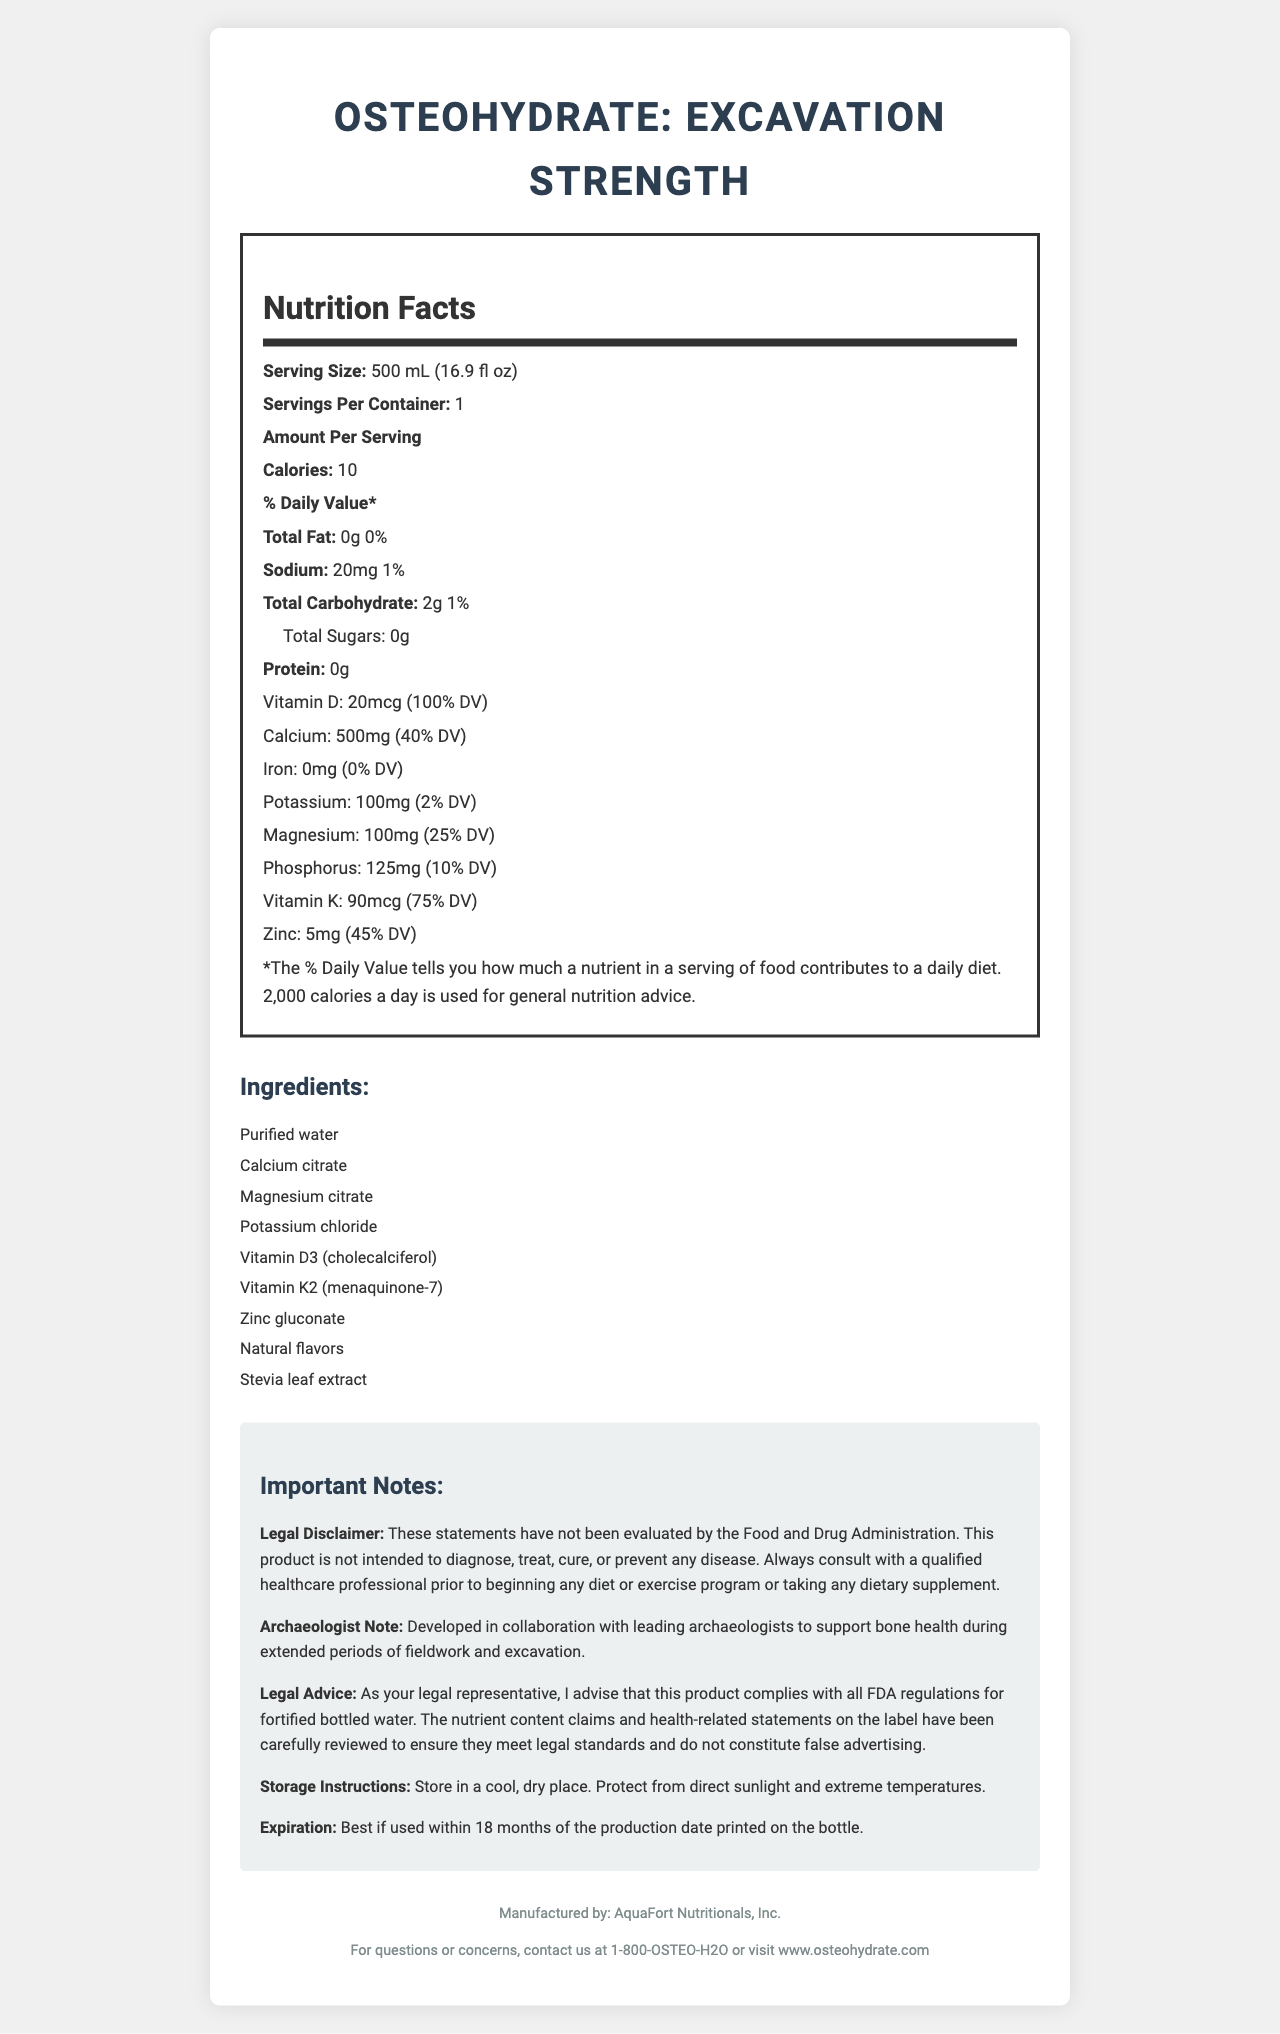what is the serving size of OsteoHydrate: Excavation Strength? The serving size is clearly stated in the Nutrition Facts section at the top.
Answer: 500 mL (16.9 fl oz) how many calories are in one serving? The document specifies the number of calories per serving in the Amount Per Serving section.
Answer: 10 calories which vitamin provides 100% of the daily value? The document lists "Vitamin D: 20mcg (100% DV)" under the Amount Per Serving section.
Answer: Vitamin D what is the sodium content in one serving? The sodium content is listed under Amount Per Serving, showing 20mg and its daily value percentage as 1%.
Answer: 20 mg (1% DV) name three key nutrients that support bone health mentioned in the document The document lists these nutrients and their significant daily value percentages, suggesting their importance in bone health.
Answer: Vitamin D, Calcium, Magnesium how many grams of protein does this product contain? The document states that the protein content is 0 grams.
Answer: 0 grams does the product contain natural flavors? Under the Ingredients section, "Natural flavors" is listed as one of the ingredients.
Answer: Yes which ingredient serves as a natural sweetener in the product? A. Stevia leaf extract B. Aspartame C. Sucralose D. Honey The Ingredients list shows "Stevia leaf extract," known for its natural sweetening properties.
Answer: A. Stevia leaf extract what percentage of the daily value of calcium does one serving provide? The document states that the calcium content is 500mg, which is 40% of the daily value.
Answer: 40% DV which of these nutrients are not present in the product? I. Iron II. Protein III. Sodium The document mentions 0mg (0% DV) for Iron and 0g for Protein, indicating their absence.
Answer: I. Iron and II. Protein what is the purpose of the product according to the archaeologist note? The Archaeologist Note specifies this purpose.
Answer: To support bone health during extended periods of fieldwork and excavation how long is the product best used after the production date? The Expiration section mentions that the product is best if used within 18 months of the production date.
Answer: Within 18 months is this product intended to diagnose, treat, cure, or prevent any disease? The Legal Disclaimer clearly states that the product is not intended to diagnose, treat, cure, or prevent any disease.
Answer: No identify the manufacturer of this product This information is given in the footer of the document.
Answer: AquaFort Nutritionals, Inc. summarize the main purpose and key components of this document This summary covers the key points including the product's purpose, contents, and additional notes provided in the document.
Answer: The document provides detailed Nutrition Facts for OsteoHydrate: Excavation Strength, a fortified bottled water designed to support bone health for archaeologists. It includes serving size, calories, and nutrient contents like Vitamin D, Calcium, and others, along with ingredients, legal disclaimers, and storage instructions. which vitamins are included in OsteoHydrate: Excavation Strength? The document lists Vitamin D3 (cholecalciferol) and Vitamin K (menaquinone-7), highlighting their presence in the product.
Answer: Vitamin D and Vitamin K what is the contact information for questions or concerns about the product? This is provided in the footer, under Contact Information.
Answer: 1-800-OSTEO-H2O or visit www.osteohydrate.com does the document mention the physical location of the manufacturer? The document does not provide a specific physical address for the manufacturer, only the name and contact information.
Answer: Not enough information what is the nutrient content claim compliance advised by? A. Food and Drug Administration B. Federal Trade Commission C. Registered Dietitian D. Legal Representative The Legal Advice section states that the label claims have been reviewed for compliance by me, the legal representative.
Answer: D. Legal Representative which ingredient is specifically stated to contain different forms in the product? I. Vitamin D II. Magnesium III. Vitamin K The Ingredients list specifies "Vitamin K2 (menaquinone-7)" suggesting the presence of a specific form of Vitamin K.
Answer: III. Vitamin K 